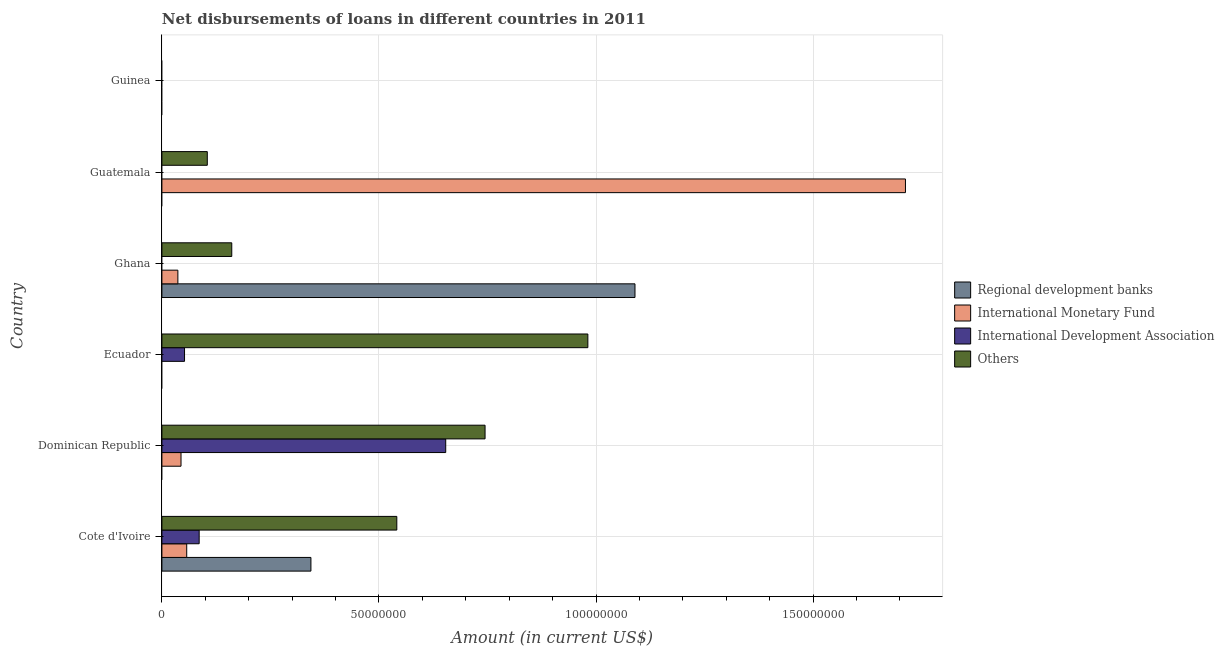How many bars are there on the 4th tick from the bottom?
Provide a short and direct response. 3. What is the label of the 4th group of bars from the top?
Offer a very short reply. Ecuador. In how many cases, is the number of bars for a given country not equal to the number of legend labels?
Your response must be concise. 5. What is the amount of loan disimbursed by other organisations in Cote d'Ivoire?
Keep it short and to the point. 5.41e+07. Across all countries, what is the maximum amount of loan disimbursed by other organisations?
Your answer should be very brief. 9.81e+07. Across all countries, what is the minimum amount of loan disimbursed by regional development banks?
Your answer should be very brief. 0. What is the total amount of loan disimbursed by other organisations in the graph?
Give a very brief answer. 2.53e+08. What is the difference between the amount of loan disimbursed by other organisations in Dominican Republic and that in Ghana?
Make the answer very short. 5.83e+07. What is the difference between the amount of loan disimbursed by international development association in Guatemala and the amount of loan disimbursed by regional development banks in Cote d'Ivoire?
Make the answer very short. -3.43e+07. What is the average amount of loan disimbursed by regional development banks per country?
Make the answer very short. 2.39e+07. What is the difference between the amount of loan disimbursed by international development association and amount of loan disimbursed by other organisations in Dominican Republic?
Keep it short and to the point. -9.06e+06. In how many countries, is the amount of loan disimbursed by regional development banks greater than 150000000 US$?
Make the answer very short. 0. What is the ratio of the amount of loan disimbursed by international monetary fund in Cote d'Ivoire to that in Dominican Republic?
Your answer should be very brief. 1.3. What is the difference between the highest and the second highest amount of loan disimbursed by other organisations?
Your answer should be very brief. 2.37e+07. What is the difference between the highest and the lowest amount of loan disimbursed by international development association?
Ensure brevity in your answer.  6.54e+07. Is the sum of the amount of loan disimbursed by international development association in Cote d'Ivoire and Ecuador greater than the maximum amount of loan disimbursed by other organisations across all countries?
Offer a terse response. No. Is it the case that in every country, the sum of the amount of loan disimbursed by regional development banks and amount of loan disimbursed by international development association is greater than the sum of amount of loan disimbursed by international monetary fund and amount of loan disimbursed by other organisations?
Ensure brevity in your answer.  No. Are all the bars in the graph horizontal?
Make the answer very short. Yes. How many countries are there in the graph?
Make the answer very short. 6. What is the difference between two consecutive major ticks on the X-axis?
Make the answer very short. 5.00e+07. How many legend labels are there?
Ensure brevity in your answer.  4. What is the title of the graph?
Ensure brevity in your answer.  Net disbursements of loans in different countries in 2011. What is the label or title of the Y-axis?
Provide a succinct answer. Country. What is the Amount (in current US$) of Regional development banks in Cote d'Ivoire?
Give a very brief answer. 3.43e+07. What is the Amount (in current US$) in International Monetary Fund in Cote d'Ivoire?
Your answer should be compact. 5.72e+06. What is the Amount (in current US$) of International Development Association in Cote d'Ivoire?
Offer a terse response. 8.58e+06. What is the Amount (in current US$) in Others in Cote d'Ivoire?
Keep it short and to the point. 5.41e+07. What is the Amount (in current US$) in Regional development banks in Dominican Republic?
Offer a terse response. 0. What is the Amount (in current US$) in International Monetary Fund in Dominican Republic?
Keep it short and to the point. 4.40e+06. What is the Amount (in current US$) in International Development Association in Dominican Republic?
Provide a short and direct response. 6.54e+07. What is the Amount (in current US$) in Others in Dominican Republic?
Keep it short and to the point. 7.44e+07. What is the Amount (in current US$) of International Development Association in Ecuador?
Your response must be concise. 5.21e+06. What is the Amount (in current US$) of Others in Ecuador?
Make the answer very short. 9.81e+07. What is the Amount (in current US$) of Regional development banks in Ghana?
Offer a terse response. 1.09e+08. What is the Amount (in current US$) in International Monetary Fund in Ghana?
Your answer should be compact. 3.68e+06. What is the Amount (in current US$) of Others in Ghana?
Your response must be concise. 1.61e+07. What is the Amount (in current US$) of Regional development banks in Guatemala?
Give a very brief answer. 0. What is the Amount (in current US$) of International Monetary Fund in Guatemala?
Make the answer very short. 1.71e+08. What is the Amount (in current US$) of Others in Guatemala?
Make the answer very short. 1.05e+07. What is the Amount (in current US$) of Regional development banks in Guinea?
Offer a very short reply. 0. What is the Amount (in current US$) in International Development Association in Guinea?
Give a very brief answer. 0. Across all countries, what is the maximum Amount (in current US$) of Regional development banks?
Your response must be concise. 1.09e+08. Across all countries, what is the maximum Amount (in current US$) of International Monetary Fund?
Your answer should be very brief. 1.71e+08. Across all countries, what is the maximum Amount (in current US$) of International Development Association?
Make the answer very short. 6.54e+07. Across all countries, what is the maximum Amount (in current US$) in Others?
Make the answer very short. 9.81e+07. Across all countries, what is the minimum Amount (in current US$) in International Monetary Fund?
Give a very brief answer. 0. Across all countries, what is the minimum Amount (in current US$) in International Development Association?
Your response must be concise. 0. Across all countries, what is the minimum Amount (in current US$) of Others?
Give a very brief answer. 0. What is the total Amount (in current US$) of Regional development banks in the graph?
Give a very brief answer. 1.43e+08. What is the total Amount (in current US$) of International Monetary Fund in the graph?
Provide a short and direct response. 1.85e+08. What is the total Amount (in current US$) in International Development Association in the graph?
Your answer should be very brief. 7.92e+07. What is the total Amount (in current US$) in Others in the graph?
Your response must be concise. 2.53e+08. What is the difference between the Amount (in current US$) in International Monetary Fund in Cote d'Ivoire and that in Dominican Republic?
Keep it short and to the point. 1.32e+06. What is the difference between the Amount (in current US$) of International Development Association in Cote d'Ivoire and that in Dominican Republic?
Give a very brief answer. -5.68e+07. What is the difference between the Amount (in current US$) of Others in Cote d'Ivoire and that in Dominican Republic?
Make the answer very short. -2.03e+07. What is the difference between the Amount (in current US$) in International Development Association in Cote d'Ivoire and that in Ecuador?
Provide a succinct answer. 3.37e+06. What is the difference between the Amount (in current US$) of Others in Cote d'Ivoire and that in Ecuador?
Offer a very short reply. -4.40e+07. What is the difference between the Amount (in current US$) of Regional development banks in Cote d'Ivoire and that in Ghana?
Provide a short and direct response. -7.46e+07. What is the difference between the Amount (in current US$) of International Monetary Fund in Cote d'Ivoire and that in Ghana?
Provide a succinct answer. 2.04e+06. What is the difference between the Amount (in current US$) in Others in Cote d'Ivoire and that in Ghana?
Make the answer very short. 3.80e+07. What is the difference between the Amount (in current US$) in International Monetary Fund in Cote d'Ivoire and that in Guatemala?
Ensure brevity in your answer.  -1.66e+08. What is the difference between the Amount (in current US$) in Others in Cote d'Ivoire and that in Guatemala?
Provide a short and direct response. 4.37e+07. What is the difference between the Amount (in current US$) in International Development Association in Dominican Republic and that in Ecuador?
Offer a terse response. 6.02e+07. What is the difference between the Amount (in current US$) in Others in Dominican Republic and that in Ecuador?
Provide a succinct answer. -2.37e+07. What is the difference between the Amount (in current US$) in International Monetary Fund in Dominican Republic and that in Ghana?
Give a very brief answer. 7.23e+05. What is the difference between the Amount (in current US$) in Others in Dominican Republic and that in Ghana?
Keep it short and to the point. 5.83e+07. What is the difference between the Amount (in current US$) in International Monetary Fund in Dominican Republic and that in Guatemala?
Offer a terse response. -1.67e+08. What is the difference between the Amount (in current US$) in Others in Dominican Republic and that in Guatemala?
Your response must be concise. 6.40e+07. What is the difference between the Amount (in current US$) of Others in Ecuador and that in Ghana?
Your answer should be compact. 8.20e+07. What is the difference between the Amount (in current US$) of Others in Ecuador and that in Guatemala?
Provide a succinct answer. 8.77e+07. What is the difference between the Amount (in current US$) of International Monetary Fund in Ghana and that in Guatemala?
Your response must be concise. -1.68e+08. What is the difference between the Amount (in current US$) of Others in Ghana and that in Guatemala?
Your response must be concise. 5.63e+06. What is the difference between the Amount (in current US$) of Regional development banks in Cote d'Ivoire and the Amount (in current US$) of International Monetary Fund in Dominican Republic?
Your answer should be very brief. 2.99e+07. What is the difference between the Amount (in current US$) in Regional development banks in Cote d'Ivoire and the Amount (in current US$) in International Development Association in Dominican Republic?
Make the answer very short. -3.10e+07. What is the difference between the Amount (in current US$) in Regional development banks in Cote d'Ivoire and the Amount (in current US$) in Others in Dominican Republic?
Your response must be concise. -4.01e+07. What is the difference between the Amount (in current US$) of International Monetary Fund in Cote d'Ivoire and the Amount (in current US$) of International Development Association in Dominican Republic?
Keep it short and to the point. -5.97e+07. What is the difference between the Amount (in current US$) of International Monetary Fund in Cote d'Ivoire and the Amount (in current US$) of Others in Dominican Republic?
Your response must be concise. -6.87e+07. What is the difference between the Amount (in current US$) of International Development Association in Cote d'Ivoire and the Amount (in current US$) of Others in Dominican Republic?
Provide a short and direct response. -6.59e+07. What is the difference between the Amount (in current US$) in Regional development banks in Cote d'Ivoire and the Amount (in current US$) in International Development Association in Ecuador?
Make the answer very short. 2.91e+07. What is the difference between the Amount (in current US$) in Regional development banks in Cote d'Ivoire and the Amount (in current US$) in Others in Ecuador?
Offer a very short reply. -6.38e+07. What is the difference between the Amount (in current US$) in International Monetary Fund in Cote d'Ivoire and the Amount (in current US$) in International Development Association in Ecuador?
Ensure brevity in your answer.  5.04e+05. What is the difference between the Amount (in current US$) of International Monetary Fund in Cote d'Ivoire and the Amount (in current US$) of Others in Ecuador?
Give a very brief answer. -9.24e+07. What is the difference between the Amount (in current US$) in International Development Association in Cote d'Ivoire and the Amount (in current US$) in Others in Ecuador?
Make the answer very short. -8.95e+07. What is the difference between the Amount (in current US$) in Regional development banks in Cote d'Ivoire and the Amount (in current US$) in International Monetary Fund in Ghana?
Make the answer very short. 3.06e+07. What is the difference between the Amount (in current US$) of Regional development banks in Cote d'Ivoire and the Amount (in current US$) of Others in Ghana?
Keep it short and to the point. 1.82e+07. What is the difference between the Amount (in current US$) in International Monetary Fund in Cote d'Ivoire and the Amount (in current US$) in Others in Ghana?
Ensure brevity in your answer.  -1.04e+07. What is the difference between the Amount (in current US$) of International Development Association in Cote d'Ivoire and the Amount (in current US$) of Others in Ghana?
Make the answer very short. -7.51e+06. What is the difference between the Amount (in current US$) of Regional development banks in Cote d'Ivoire and the Amount (in current US$) of International Monetary Fund in Guatemala?
Offer a very short reply. -1.37e+08. What is the difference between the Amount (in current US$) in Regional development banks in Cote d'Ivoire and the Amount (in current US$) in Others in Guatemala?
Ensure brevity in your answer.  2.39e+07. What is the difference between the Amount (in current US$) of International Monetary Fund in Cote d'Ivoire and the Amount (in current US$) of Others in Guatemala?
Keep it short and to the point. -4.74e+06. What is the difference between the Amount (in current US$) in International Development Association in Cote d'Ivoire and the Amount (in current US$) in Others in Guatemala?
Provide a short and direct response. -1.87e+06. What is the difference between the Amount (in current US$) in International Monetary Fund in Dominican Republic and the Amount (in current US$) in International Development Association in Ecuador?
Give a very brief answer. -8.11e+05. What is the difference between the Amount (in current US$) in International Monetary Fund in Dominican Republic and the Amount (in current US$) in Others in Ecuador?
Your answer should be compact. -9.37e+07. What is the difference between the Amount (in current US$) of International Development Association in Dominican Republic and the Amount (in current US$) of Others in Ecuador?
Keep it short and to the point. -3.27e+07. What is the difference between the Amount (in current US$) of International Monetary Fund in Dominican Republic and the Amount (in current US$) of Others in Ghana?
Your response must be concise. -1.17e+07. What is the difference between the Amount (in current US$) in International Development Association in Dominican Republic and the Amount (in current US$) in Others in Ghana?
Your answer should be very brief. 4.93e+07. What is the difference between the Amount (in current US$) of International Monetary Fund in Dominican Republic and the Amount (in current US$) of Others in Guatemala?
Ensure brevity in your answer.  -6.06e+06. What is the difference between the Amount (in current US$) in International Development Association in Dominican Republic and the Amount (in current US$) in Others in Guatemala?
Keep it short and to the point. 5.49e+07. What is the difference between the Amount (in current US$) in International Development Association in Ecuador and the Amount (in current US$) in Others in Ghana?
Offer a terse response. -1.09e+07. What is the difference between the Amount (in current US$) in International Development Association in Ecuador and the Amount (in current US$) in Others in Guatemala?
Offer a terse response. -5.24e+06. What is the difference between the Amount (in current US$) in Regional development banks in Ghana and the Amount (in current US$) in International Monetary Fund in Guatemala?
Your answer should be very brief. -6.23e+07. What is the difference between the Amount (in current US$) in Regional development banks in Ghana and the Amount (in current US$) in Others in Guatemala?
Make the answer very short. 9.85e+07. What is the difference between the Amount (in current US$) of International Monetary Fund in Ghana and the Amount (in current US$) of Others in Guatemala?
Offer a terse response. -6.78e+06. What is the average Amount (in current US$) in Regional development banks per country?
Your answer should be compact. 2.39e+07. What is the average Amount (in current US$) of International Monetary Fund per country?
Your answer should be compact. 3.08e+07. What is the average Amount (in current US$) in International Development Association per country?
Provide a short and direct response. 1.32e+07. What is the average Amount (in current US$) of Others per country?
Give a very brief answer. 4.22e+07. What is the difference between the Amount (in current US$) of Regional development banks and Amount (in current US$) of International Monetary Fund in Cote d'Ivoire?
Provide a short and direct response. 2.86e+07. What is the difference between the Amount (in current US$) in Regional development banks and Amount (in current US$) in International Development Association in Cote d'Ivoire?
Offer a very short reply. 2.57e+07. What is the difference between the Amount (in current US$) in Regional development banks and Amount (in current US$) in Others in Cote d'Ivoire?
Ensure brevity in your answer.  -1.98e+07. What is the difference between the Amount (in current US$) in International Monetary Fund and Amount (in current US$) in International Development Association in Cote d'Ivoire?
Offer a terse response. -2.87e+06. What is the difference between the Amount (in current US$) of International Monetary Fund and Amount (in current US$) of Others in Cote d'Ivoire?
Your answer should be compact. -4.84e+07. What is the difference between the Amount (in current US$) in International Development Association and Amount (in current US$) in Others in Cote d'Ivoire?
Your answer should be compact. -4.55e+07. What is the difference between the Amount (in current US$) in International Monetary Fund and Amount (in current US$) in International Development Association in Dominican Republic?
Offer a terse response. -6.10e+07. What is the difference between the Amount (in current US$) in International Monetary Fund and Amount (in current US$) in Others in Dominican Republic?
Keep it short and to the point. -7.00e+07. What is the difference between the Amount (in current US$) in International Development Association and Amount (in current US$) in Others in Dominican Republic?
Offer a very short reply. -9.06e+06. What is the difference between the Amount (in current US$) in International Development Association and Amount (in current US$) in Others in Ecuador?
Give a very brief answer. -9.29e+07. What is the difference between the Amount (in current US$) of Regional development banks and Amount (in current US$) of International Monetary Fund in Ghana?
Provide a short and direct response. 1.05e+08. What is the difference between the Amount (in current US$) in Regional development banks and Amount (in current US$) in Others in Ghana?
Provide a short and direct response. 9.29e+07. What is the difference between the Amount (in current US$) in International Monetary Fund and Amount (in current US$) in Others in Ghana?
Provide a succinct answer. -1.24e+07. What is the difference between the Amount (in current US$) in International Monetary Fund and Amount (in current US$) in Others in Guatemala?
Provide a short and direct response. 1.61e+08. What is the ratio of the Amount (in current US$) in International Monetary Fund in Cote d'Ivoire to that in Dominican Republic?
Ensure brevity in your answer.  1.3. What is the ratio of the Amount (in current US$) in International Development Association in Cote d'Ivoire to that in Dominican Republic?
Your response must be concise. 0.13. What is the ratio of the Amount (in current US$) of Others in Cote d'Ivoire to that in Dominican Republic?
Give a very brief answer. 0.73. What is the ratio of the Amount (in current US$) of International Development Association in Cote d'Ivoire to that in Ecuador?
Your answer should be very brief. 1.65. What is the ratio of the Amount (in current US$) in Others in Cote d'Ivoire to that in Ecuador?
Make the answer very short. 0.55. What is the ratio of the Amount (in current US$) of Regional development banks in Cote d'Ivoire to that in Ghana?
Your answer should be compact. 0.32. What is the ratio of the Amount (in current US$) of International Monetary Fund in Cote d'Ivoire to that in Ghana?
Give a very brief answer. 1.55. What is the ratio of the Amount (in current US$) in Others in Cote d'Ivoire to that in Ghana?
Your answer should be compact. 3.36. What is the ratio of the Amount (in current US$) in International Monetary Fund in Cote d'Ivoire to that in Guatemala?
Make the answer very short. 0.03. What is the ratio of the Amount (in current US$) in Others in Cote d'Ivoire to that in Guatemala?
Keep it short and to the point. 5.17. What is the ratio of the Amount (in current US$) of International Development Association in Dominican Republic to that in Ecuador?
Make the answer very short. 12.54. What is the ratio of the Amount (in current US$) in Others in Dominican Republic to that in Ecuador?
Offer a terse response. 0.76. What is the ratio of the Amount (in current US$) of International Monetary Fund in Dominican Republic to that in Ghana?
Make the answer very short. 1.2. What is the ratio of the Amount (in current US$) in Others in Dominican Republic to that in Ghana?
Your answer should be compact. 4.63. What is the ratio of the Amount (in current US$) in International Monetary Fund in Dominican Republic to that in Guatemala?
Offer a very short reply. 0.03. What is the ratio of the Amount (in current US$) in Others in Dominican Republic to that in Guatemala?
Your answer should be very brief. 7.12. What is the ratio of the Amount (in current US$) of Others in Ecuador to that in Ghana?
Provide a short and direct response. 6.1. What is the ratio of the Amount (in current US$) of Others in Ecuador to that in Guatemala?
Provide a succinct answer. 9.38. What is the ratio of the Amount (in current US$) of International Monetary Fund in Ghana to that in Guatemala?
Keep it short and to the point. 0.02. What is the ratio of the Amount (in current US$) in Others in Ghana to that in Guatemala?
Your response must be concise. 1.54. What is the difference between the highest and the second highest Amount (in current US$) of International Monetary Fund?
Offer a very short reply. 1.66e+08. What is the difference between the highest and the second highest Amount (in current US$) in International Development Association?
Ensure brevity in your answer.  5.68e+07. What is the difference between the highest and the second highest Amount (in current US$) of Others?
Keep it short and to the point. 2.37e+07. What is the difference between the highest and the lowest Amount (in current US$) in Regional development banks?
Provide a short and direct response. 1.09e+08. What is the difference between the highest and the lowest Amount (in current US$) in International Monetary Fund?
Your answer should be compact. 1.71e+08. What is the difference between the highest and the lowest Amount (in current US$) in International Development Association?
Keep it short and to the point. 6.54e+07. What is the difference between the highest and the lowest Amount (in current US$) in Others?
Provide a short and direct response. 9.81e+07. 